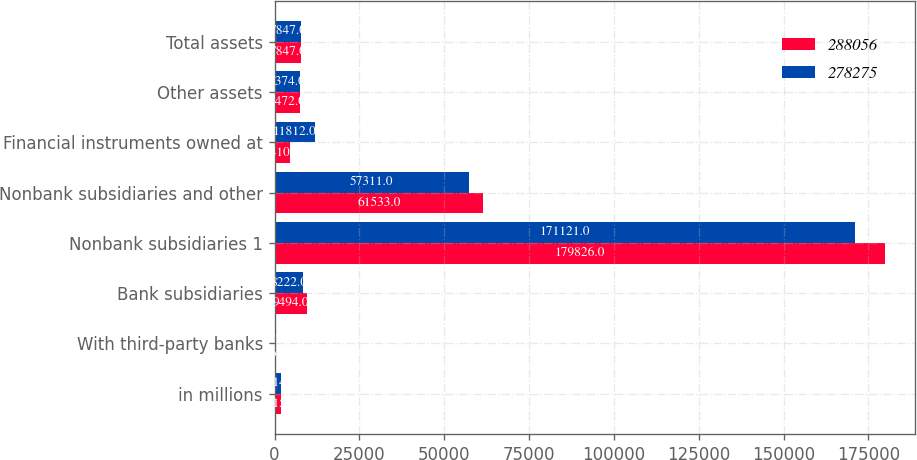<chart> <loc_0><loc_0><loc_500><loc_500><stacked_bar_chart><ecel><fcel>in millions<fcel>With third-party banks<fcel>Bank subsidiaries<fcel>Nonbank subsidiaries 1<fcel>Nonbank subsidiaries and other<fcel>Financial instruments owned at<fcel>Other assets<fcel>Total assets<nl><fcel>288056<fcel>2015<fcel>36<fcel>9494<fcel>179826<fcel>61533<fcel>4410<fcel>7472<fcel>7847<nl><fcel>278275<fcel>2014<fcel>42<fcel>8222<fcel>171121<fcel>57311<fcel>11812<fcel>7374<fcel>7847<nl></chart> 